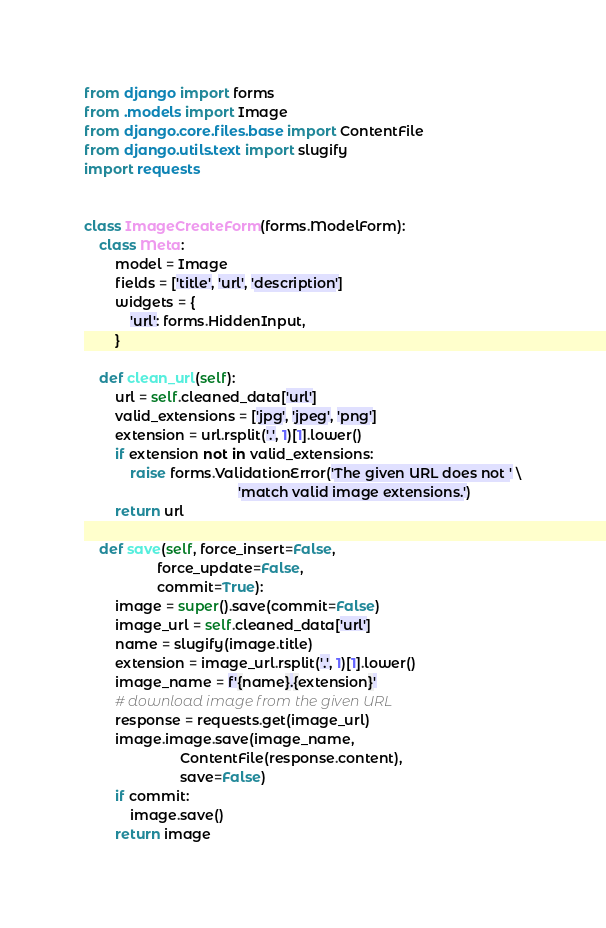Convert code to text. <code><loc_0><loc_0><loc_500><loc_500><_Python_>from django import forms
from .models import Image
from django.core.files.base import ContentFile
from django.utils.text import slugify
import requests


class ImageCreateForm(forms.ModelForm):
    class Meta:
        model = Image
        fields = ['title', 'url', 'description']
        widgets = {
            'url': forms.HiddenInput,
        }

    def clean_url(self):
        url = self.cleaned_data['url']
        valid_extensions = ['jpg', 'jpeg', 'png']
        extension = url.rsplit('.', 1)[1].lower()
        if extension not in valid_extensions:
            raise forms.ValidationError('The given URL does not ' \
                                        'match valid image extensions.')
        return url

    def save(self, force_insert=False,
                   force_update=False,
                   commit=True):
        image = super().save(commit=False)
        image_url = self.cleaned_data['url']
        name = slugify(image.title)
        extension = image_url.rsplit('.', 1)[1].lower()
        image_name = f'{name}.{extension}'
        # download image from the given URL
        response = requests.get(image_url)
        image.image.save(image_name,
                         ContentFile(response.content),
                         save=False)
        if commit:
            image.save()
        return image
</code> 